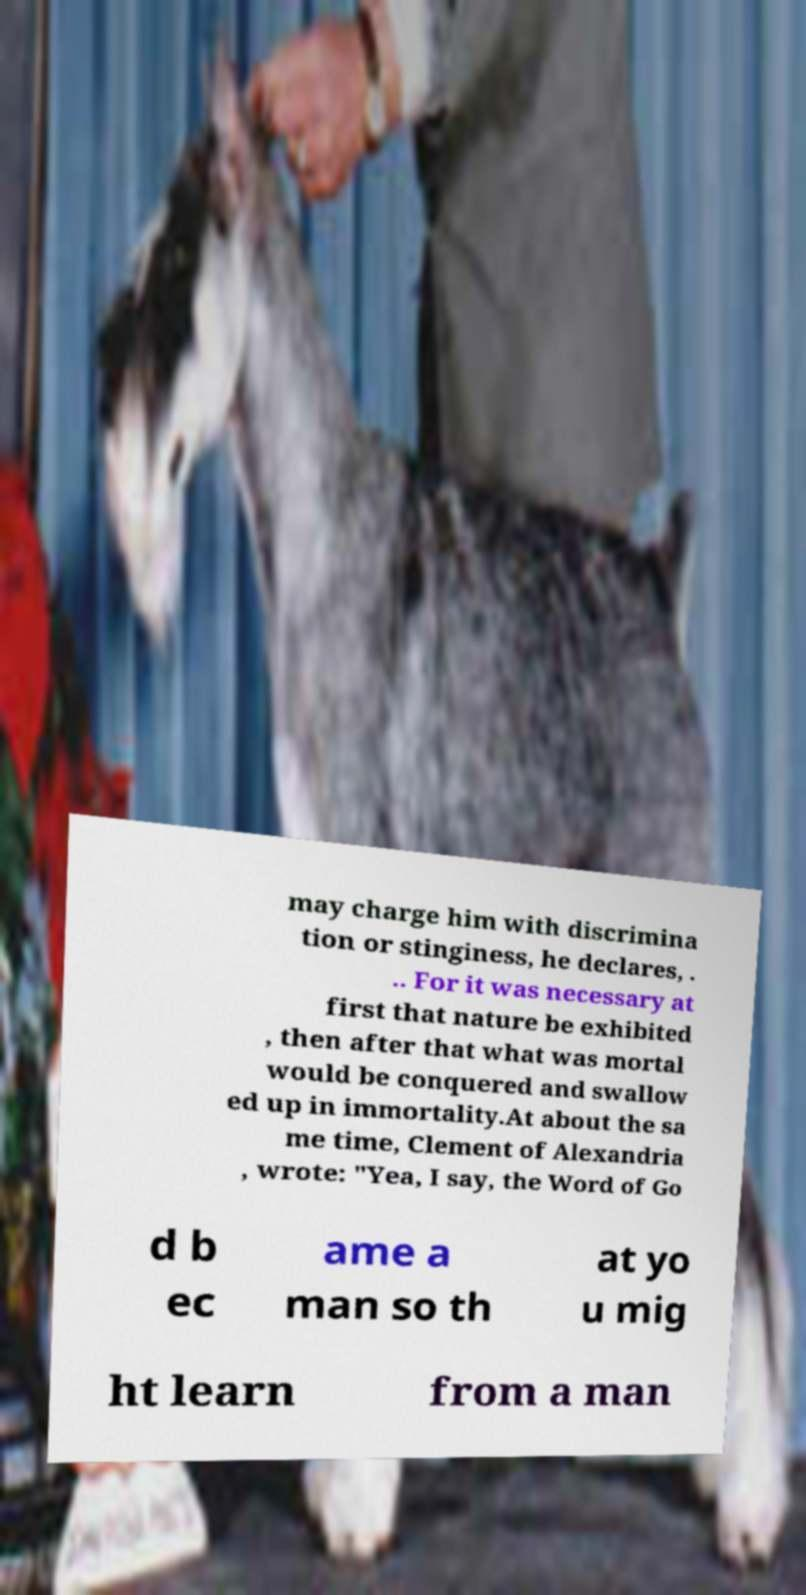Please identify and transcribe the text found in this image. may charge him with discrimina tion or stinginess, he declares, . .. For it was necessary at first that nature be exhibited , then after that what was mortal would be conquered and swallow ed up in immortality.At about the sa me time, Clement of Alexandria , wrote: "Yea, I say, the Word of Go d b ec ame a man so th at yo u mig ht learn from a man 